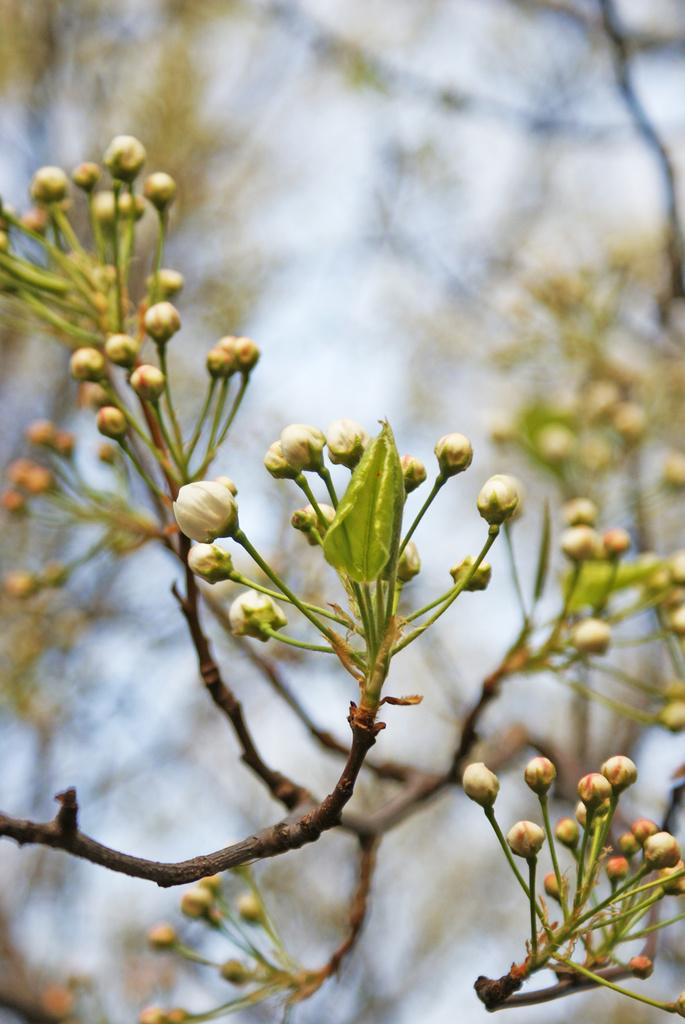What is visible in the front of the image? There are buds and leaves on stems in the front of the image. What can be seen in the background of the image? In the background, there are green leaves with stems. Can you tell me how many people are swimming in the image? There is no swimming or people present in the image; it features buds, leaves, and stems. 